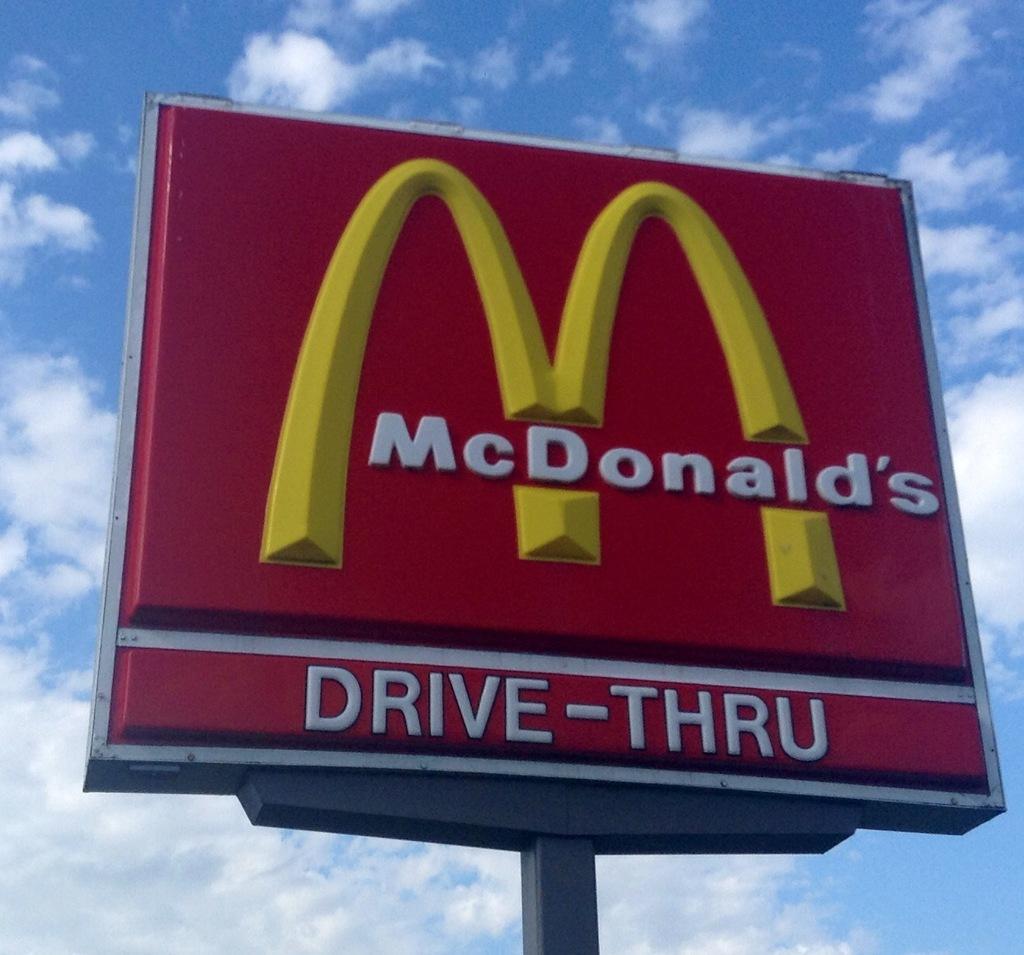Could you give a brief overview of what you see in this image? In this picture we can see a name board and in the background we can see the sky with clouds. 